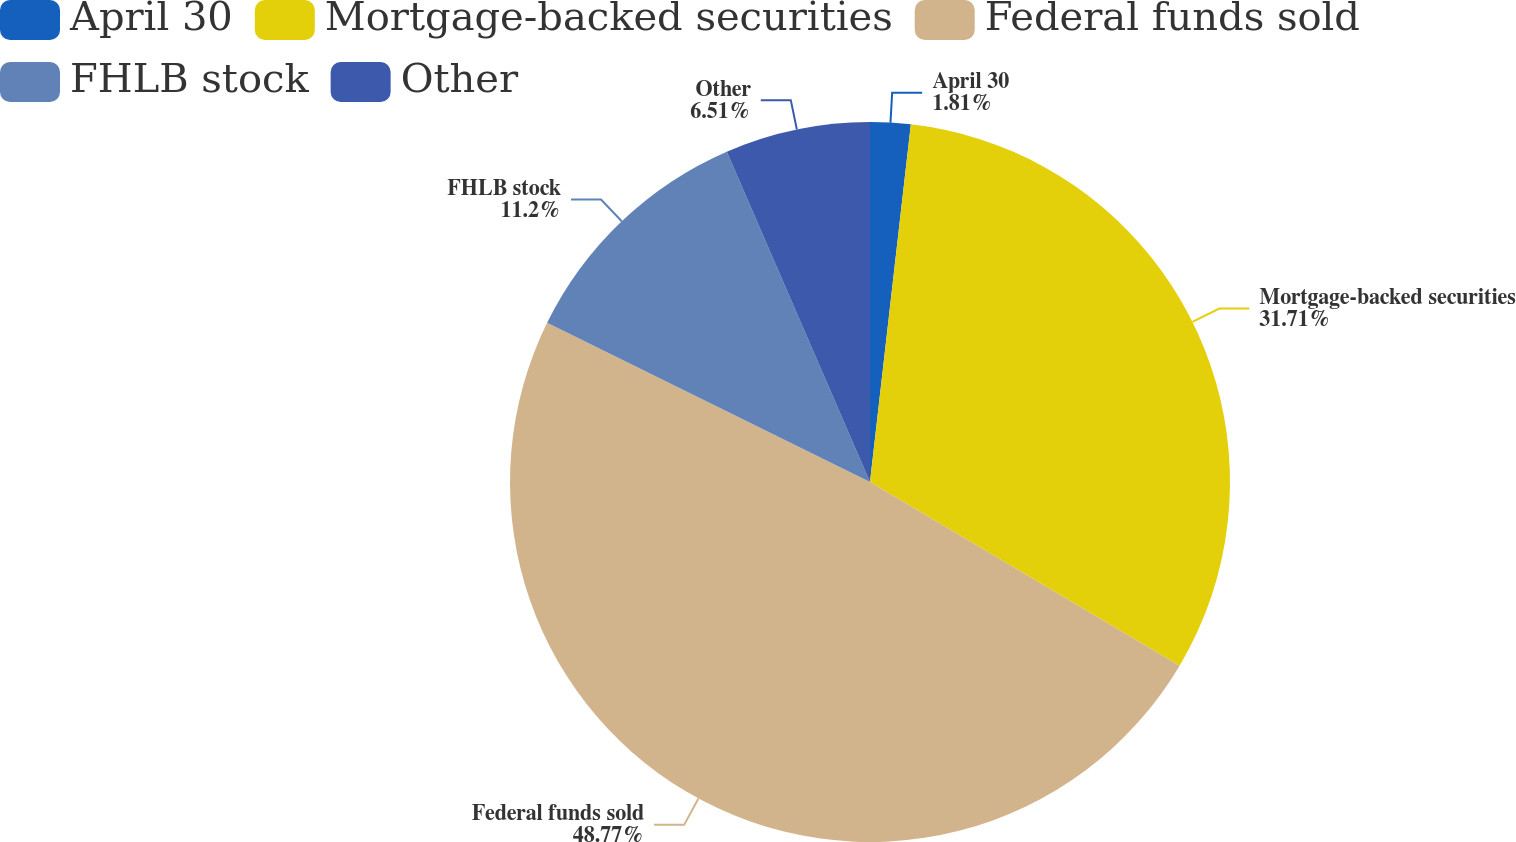Convert chart. <chart><loc_0><loc_0><loc_500><loc_500><pie_chart><fcel>April 30<fcel>Mortgage-backed securities<fcel>Federal funds sold<fcel>FHLB stock<fcel>Other<nl><fcel>1.81%<fcel>31.71%<fcel>48.76%<fcel>11.2%<fcel>6.51%<nl></chart> 